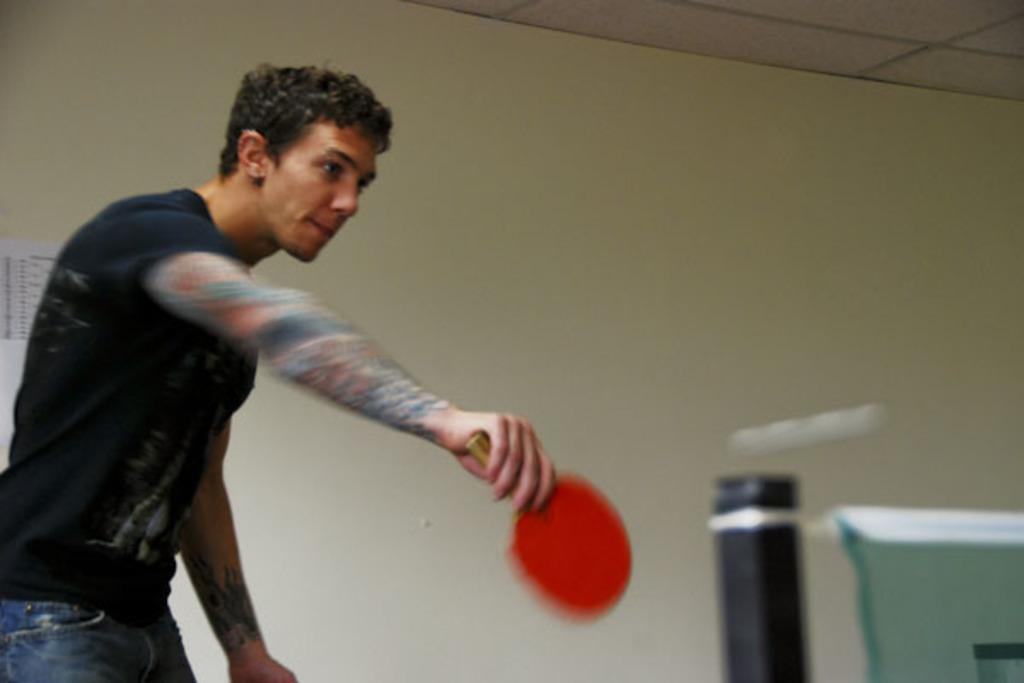In one or two sentences, can you explain what this image depicts? in this image in the center there is a person standing and holding a bat and on the right side there is net which is green in colour and there is a pole. In the background there is a poster on the wall with some text written on it 